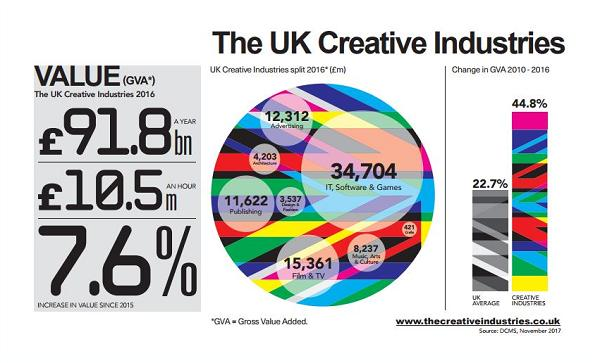Give some essential details in this illustration. The creative industries contributed a total of £91.8 billion in value to the UK economy in 2016, making a significant economic impact. In 2016, the value of the publishing sector's gross value added (GVA) was 11,622. Since 2015, there has been a 7.6% increase in value. In 2016, the GVA (Gross Value Added) for the IT, software and games sector was 34,704. 